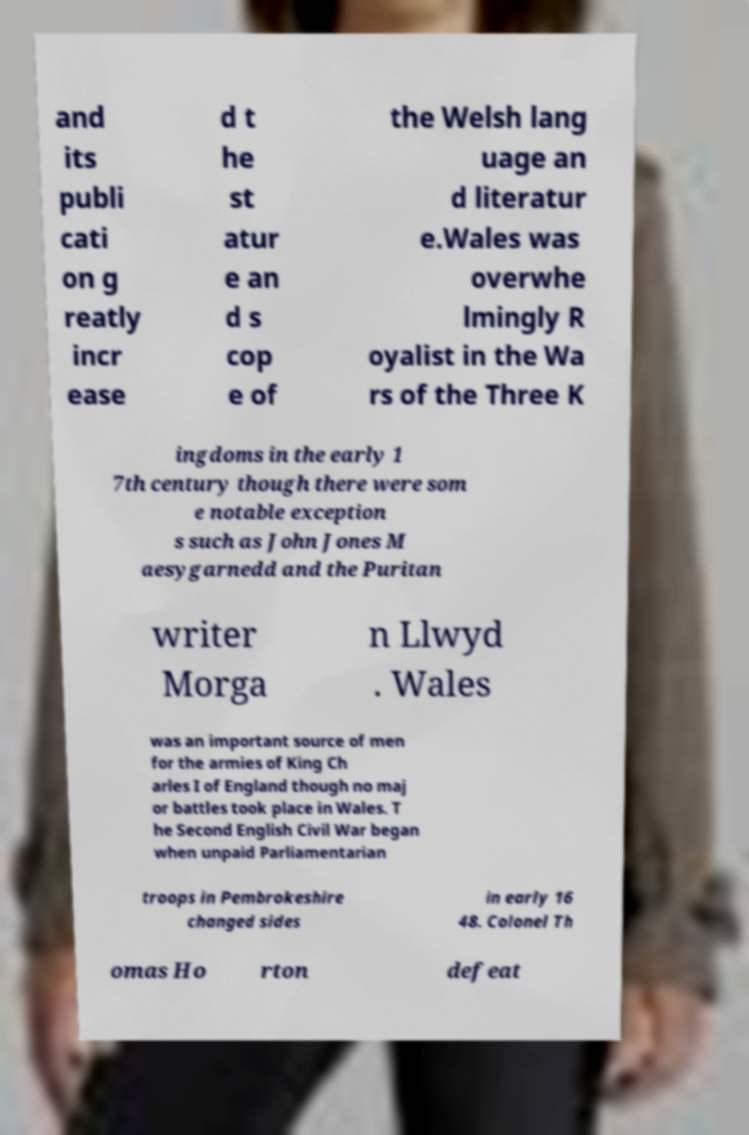Please identify and transcribe the text found in this image. and its publi cati on g reatly incr ease d t he st atur e an d s cop e of the Welsh lang uage an d literatur e.Wales was overwhe lmingly R oyalist in the Wa rs of the Three K ingdoms in the early 1 7th century though there were som e notable exception s such as John Jones M aesygarnedd and the Puritan writer Morga n Llwyd . Wales was an important source of men for the armies of King Ch arles I of England though no maj or battles took place in Wales. T he Second English Civil War began when unpaid Parliamentarian troops in Pembrokeshire changed sides in early 16 48. Colonel Th omas Ho rton defeat 